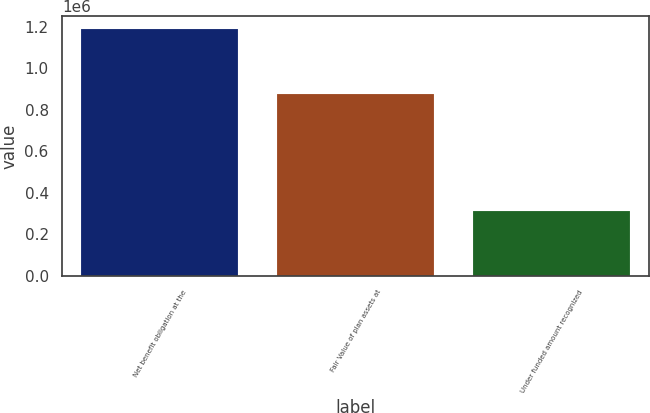<chart> <loc_0><loc_0><loc_500><loc_500><bar_chart><fcel>Net benefit obligation at the<fcel>Fair Value of plan assets at<fcel>Under funded amount recognized<nl><fcel>1.19134e+06<fcel>877950<fcel>313395<nl></chart> 